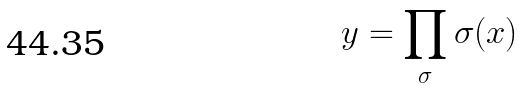Convert formula to latex. <formula><loc_0><loc_0><loc_500><loc_500>y = \prod _ { \sigma } \sigma ( x )</formula> 